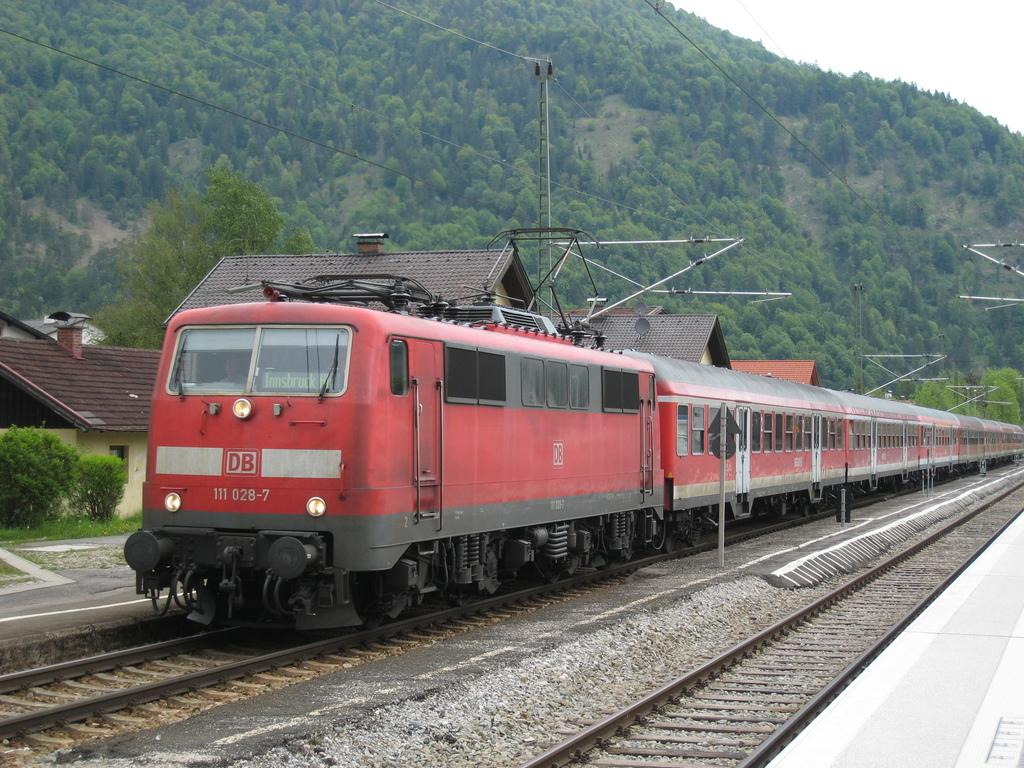Provide a one-sentence caption for the provided image. A train chugs along with DB displayed on its first car. 